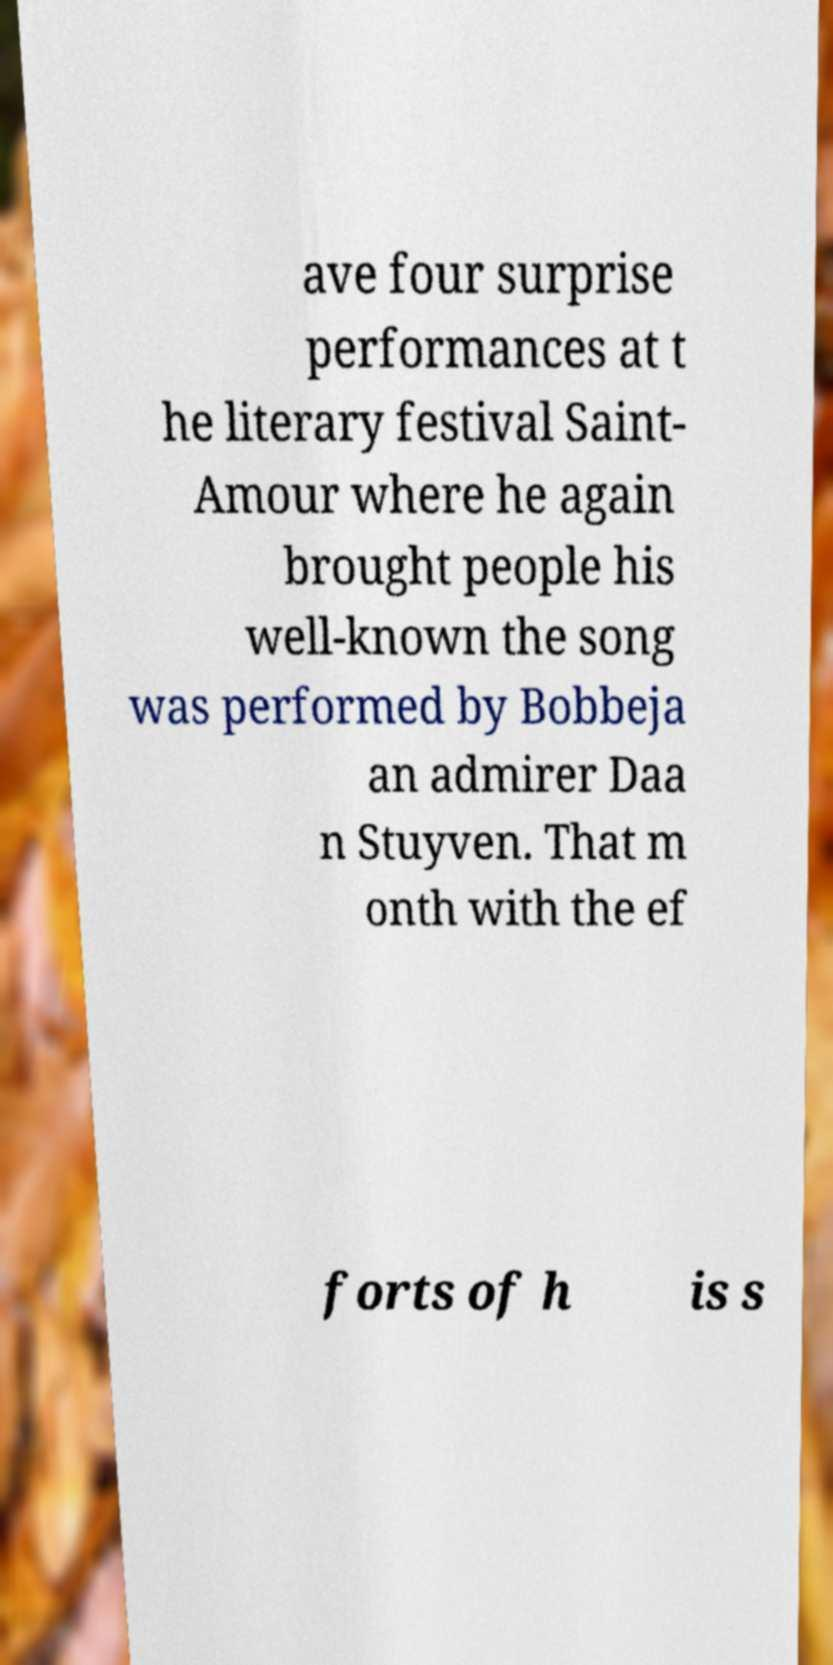Please identify and transcribe the text found in this image. ave four surprise performances at t he literary festival Saint- Amour where he again brought people his well-known the song was performed by Bobbeja an admirer Daa n Stuyven. That m onth with the ef forts of h is s 